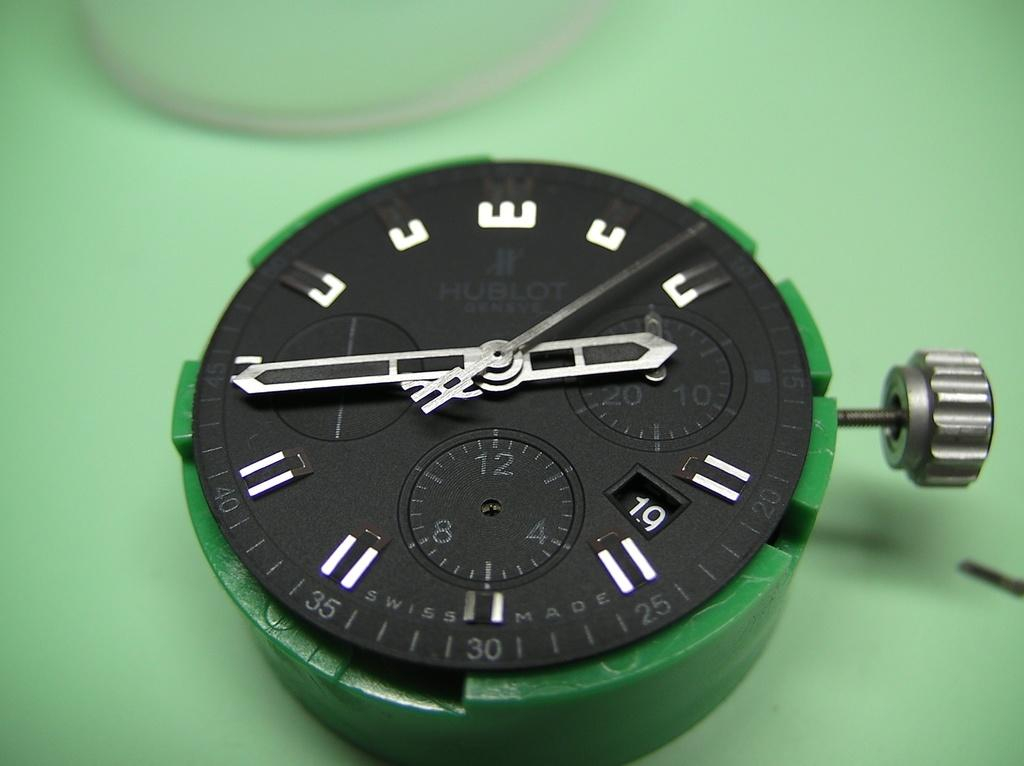<image>
Offer a succinct explanation of the picture presented. A meter that is green and black and says 12, 4 and 8 at the bottom. 